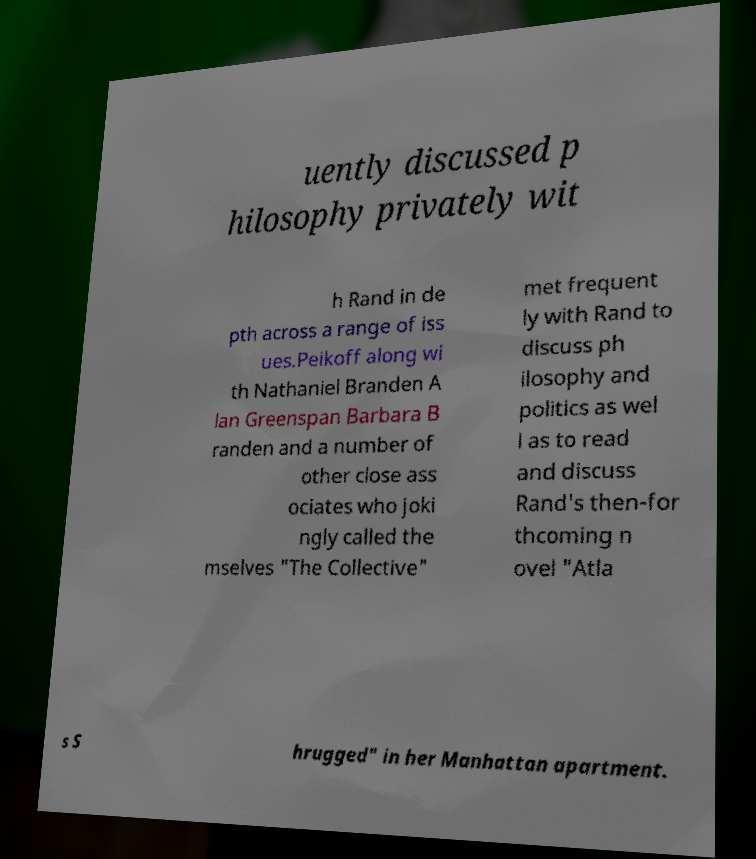For documentation purposes, I need the text within this image transcribed. Could you provide that? uently discussed p hilosophy privately wit h Rand in de pth across a range of iss ues.Peikoff along wi th Nathaniel Branden A lan Greenspan Barbara B randen and a number of other close ass ociates who joki ngly called the mselves "The Collective" met frequent ly with Rand to discuss ph ilosophy and politics as wel l as to read and discuss Rand's then-for thcoming n ovel "Atla s S hrugged" in her Manhattan apartment. 